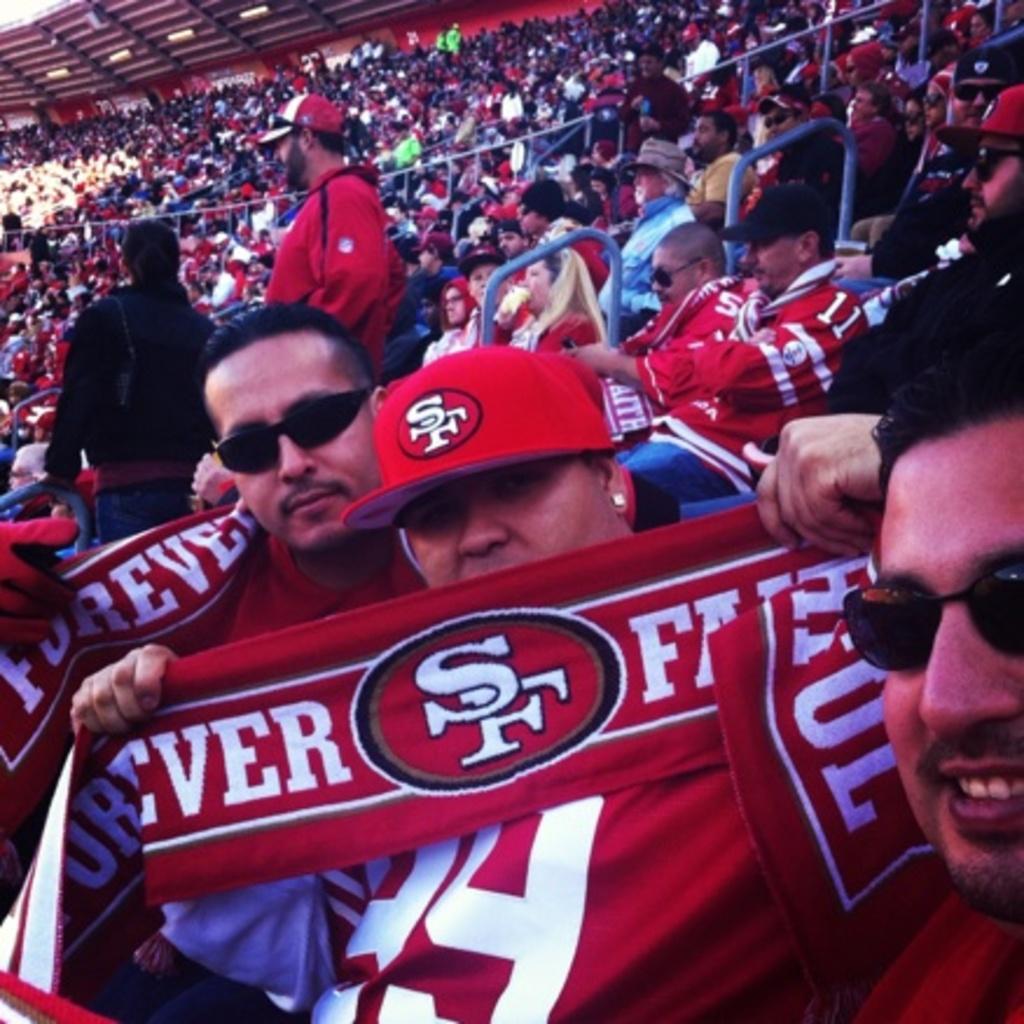What are the initials of the fan's team?
Provide a succinct answer. Sf. 